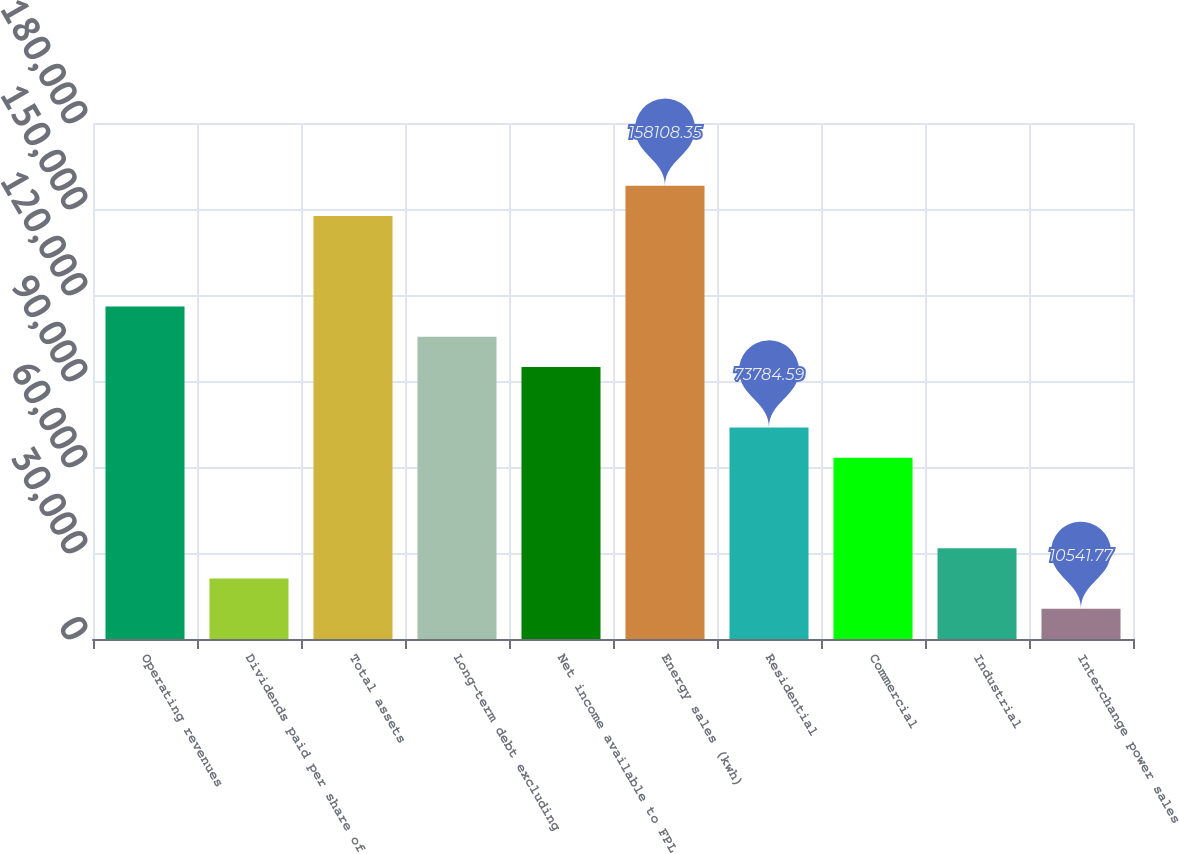Convert chart. <chart><loc_0><loc_0><loc_500><loc_500><bar_chart><fcel>Operating revenues<fcel>Dividends paid per share of<fcel>Total assets<fcel>Long-term debt excluding<fcel>Net income available to FPL<fcel>Energy sales (kwh)<fcel>Residential<fcel>Commercial<fcel>Industrial<fcel>Interchange power sales<nl><fcel>115946<fcel>21082.2<fcel>147568<fcel>105406<fcel>94865.5<fcel>158108<fcel>73784.6<fcel>63244.1<fcel>31622.7<fcel>10541.8<nl></chart> 